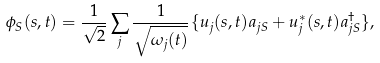Convert formula to latex. <formula><loc_0><loc_0><loc_500><loc_500>\phi _ { S } ( s , t ) = \frac { 1 } { \sqrt { 2 } } \sum _ { j } \frac { 1 } { \sqrt { \omega _ { j } ( t ) } } \{ u _ { j } ( s , t ) a _ { j S } + u _ { j } ^ { * } ( s , t ) a _ { j S } ^ { \dag } \} ,</formula> 